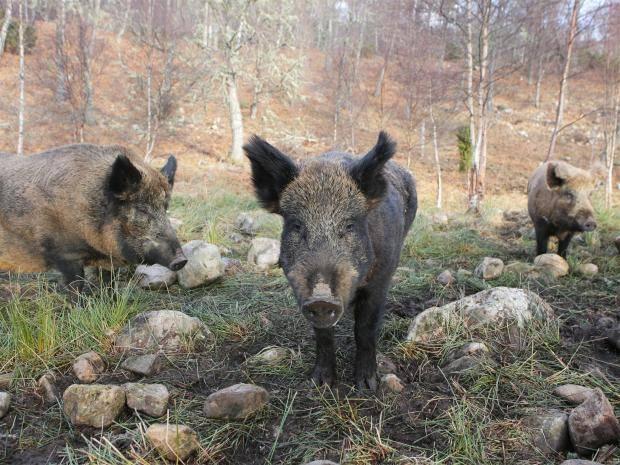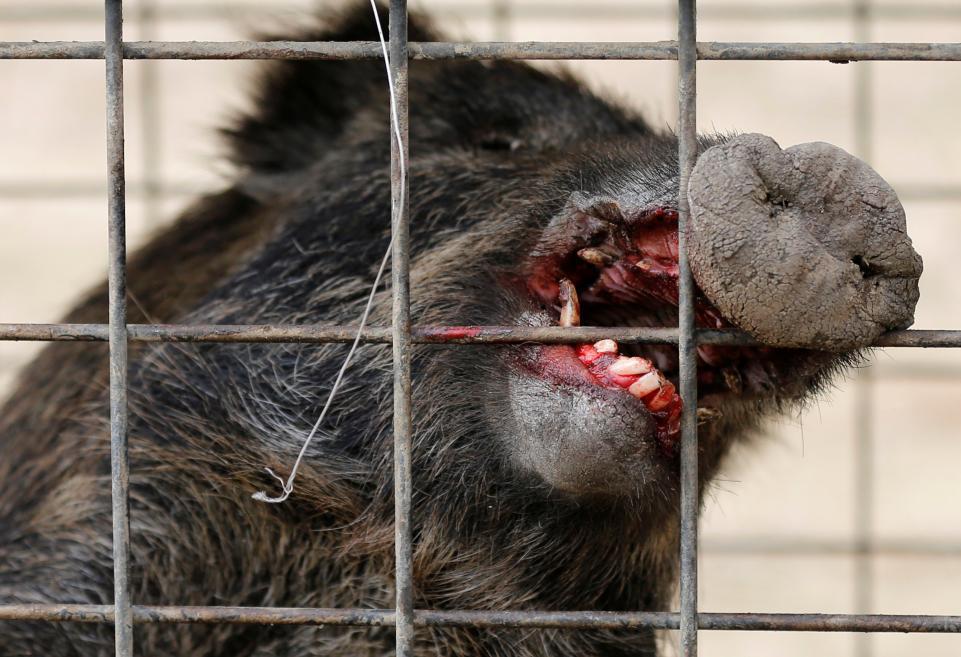The first image is the image on the left, the second image is the image on the right. For the images shown, is this caption "The pig in the left image is not alone." true? Answer yes or no. Yes. 